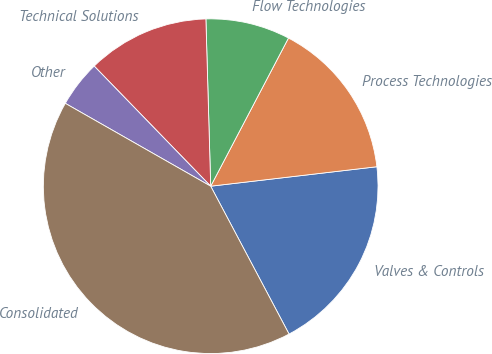<chart> <loc_0><loc_0><loc_500><loc_500><pie_chart><fcel>Valves & Controls<fcel>Process Technologies<fcel>Flow Technologies<fcel>Technical Solutions<fcel>Other<fcel>Consolidated<nl><fcel>19.1%<fcel>15.45%<fcel>8.15%<fcel>11.8%<fcel>4.5%<fcel>41.0%<nl></chart> 